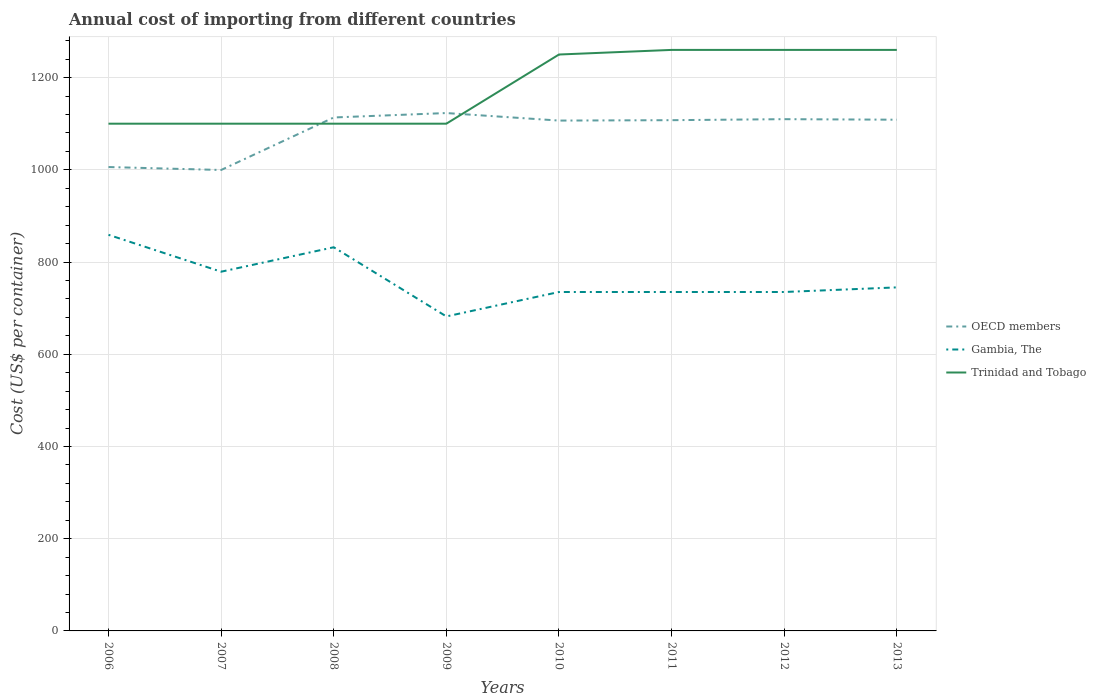How many different coloured lines are there?
Your answer should be very brief. 3. Across all years, what is the maximum total annual cost of importing in OECD members?
Give a very brief answer. 999.59. In which year was the total annual cost of importing in OECD members maximum?
Provide a short and direct response. 2007. What is the total total annual cost of importing in Trinidad and Tobago in the graph?
Give a very brief answer. -150. What is the difference between the highest and the second highest total annual cost of importing in Trinidad and Tobago?
Make the answer very short. 160. What is the difference between the highest and the lowest total annual cost of importing in OECD members?
Your response must be concise. 6. How many lines are there?
Ensure brevity in your answer.  3. What is the difference between two consecutive major ticks on the Y-axis?
Make the answer very short. 200. Are the values on the major ticks of Y-axis written in scientific E-notation?
Provide a succinct answer. No. Does the graph contain any zero values?
Your response must be concise. No. Does the graph contain grids?
Your answer should be very brief. Yes. What is the title of the graph?
Ensure brevity in your answer.  Annual cost of importing from different countries. Does "Sao Tome and Principe" appear as one of the legend labels in the graph?
Make the answer very short. No. What is the label or title of the X-axis?
Make the answer very short. Years. What is the label or title of the Y-axis?
Ensure brevity in your answer.  Cost (US$ per container). What is the Cost (US$ per container) in OECD members in 2006?
Your answer should be very brief. 1005.97. What is the Cost (US$ per container) in Gambia, The in 2006?
Give a very brief answer. 859. What is the Cost (US$ per container) in Trinidad and Tobago in 2006?
Ensure brevity in your answer.  1100. What is the Cost (US$ per container) of OECD members in 2007?
Make the answer very short. 999.59. What is the Cost (US$ per container) of Gambia, The in 2007?
Your response must be concise. 779. What is the Cost (US$ per container) in Trinidad and Tobago in 2007?
Your response must be concise. 1100. What is the Cost (US$ per container) of OECD members in 2008?
Ensure brevity in your answer.  1113.47. What is the Cost (US$ per container) in Gambia, The in 2008?
Offer a very short reply. 832. What is the Cost (US$ per container) of Trinidad and Tobago in 2008?
Make the answer very short. 1100. What is the Cost (US$ per container) in OECD members in 2009?
Offer a very short reply. 1123.06. What is the Cost (US$ per container) in Gambia, The in 2009?
Give a very brief answer. 682. What is the Cost (US$ per container) in Trinidad and Tobago in 2009?
Ensure brevity in your answer.  1100. What is the Cost (US$ per container) of OECD members in 2010?
Your answer should be compact. 1106.74. What is the Cost (US$ per container) in Gambia, The in 2010?
Your response must be concise. 735. What is the Cost (US$ per container) in Trinidad and Tobago in 2010?
Make the answer very short. 1250. What is the Cost (US$ per container) of OECD members in 2011?
Keep it short and to the point. 1107.59. What is the Cost (US$ per container) in Gambia, The in 2011?
Offer a terse response. 735. What is the Cost (US$ per container) in Trinidad and Tobago in 2011?
Provide a succinct answer. 1260. What is the Cost (US$ per container) of OECD members in 2012?
Your response must be concise. 1109.79. What is the Cost (US$ per container) of Gambia, The in 2012?
Your answer should be compact. 735. What is the Cost (US$ per container) of Trinidad and Tobago in 2012?
Make the answer very short. 1260. What is the Cost (US$ per container) in OECD members in 2013?
Give a very brief answer. 1108.61. What is the Cost (US$ per container) in Gambia, The in 2013?
Make the answer very short. 745. What is the Cost (US$ per container) of Trinidad and Tobago in 2013?
Offer a very short reply. 1260. Across all years, what is the maximum Cost (US$ per container) of OECD members?
Provide a succinct answer. 1123.06. Across all years, what is the maximum Cost (US$ per container) in Gambia, The?
Provide a short and direct response. 859. Across all years, what is the maximum Cost (US$ per container) in Trinidad and Tobago?
Your response must be concise. 1260. Across all years, what is the minimum Cost (US$ per container) of OECD members?
Provide a short and direct response. 999.59. Across all years, what is the minimum Cost (US$ per container) in Gambia, The?
Offer a very short reply. 682. Across all years, what is the minimum Cost (US$ per container) of Trinidad and Tobago?
Ensure brevity in your answer.  1100. What is the total Cost (US$ per container) of OECD members in the graph?
Offer a very short reply. 8674.82. What is the total Cost (US$ per container) of Gambia, The in the graph?
Offer a very short reply. 6102. What is the total Cost (US$ per container) in Trinidad and Tobago in the graph?
Offer a very short reply. 9430. What is the difference between the Cost (US$ per container) of OECD members in 2006 and that in 2007?
Provide a short and direct response. 6.38. What is the difference between the Cost (US$ per container) in OECD members in 2006 and that in 2008?
Provide a short and direct response. -107.5. What is the difference between the Cost (US$ per container) in Gambia, The in 2006 and that in 2008?
Provide a succinct answer. 27. What is the difference between the Cost (US$ per container) of OECD members in 2006 and that in 2009?
Your answer should be compact. -117.09. What is the difference between the Cost (US$ per container) of Gambia, The in 2006 and that in 2009?
Your response must be concise. 177. What is the difference between the Cost (US$ per container) in OECD members in 2006 and that in 2010?
Your response must be concise. -100.76. What is the difference between the Cost (US$ per container) in Gambia, The in 2006 and that in 2010?
Offer a very short reply. 124. What is the difference between the Cost (US$ per container) of Trinidad and Tobago in 2006 and that in 2010?
Offer a very short reply. -150. What is the difference between the Cost (US$ per container) in OECD members in 2006 and that in 2011?
Give a very brief answer. -101.62. What is the difference between the Cost (US$ per container) of Gambia, The in 2006 and that in 2011?
Your response must be concise. 124. What is the difference between the Cost (US$ per container) of Trinidad and Tobago in 2006 and that in 2011?
Provide a short and direct response. -160. What is the difference between the Cost (US$ per container) of OECD members in 2006 and that in 2012?
Make the answer very short. -103.82. What is the difference between the Cost (US$ per container) of Gambia, The in 2006 and that in 2012?
Your answer should be compact. 124. What is the difference between the Cost (US$ per container) of Trinidad and Tobago in 2006 and that in 2012?
Offer a very short reply. -160. What is the difference between the Cost (US$ per container) in OECD members in 2006 and that in 2013?
Make the answer very short. -102.64. What is the difference between the Cost (US$ per container) of Gambia, The in 2006 and that in 2013?
Ensure brevity in your answer.  114. What is the difference between the Cost (US$ per container) of Trinidad and Tobago in 2006 and that in 2013?
Offer a terse response. -160. What is the difference between the Cost (US$ per container) of OECD members in 2007 and that in 2008?
Offer a very short reply. -113.88. What is the difference between the Cost (US$ per container) of Gambia, The in 2007 and that in 2008?
Your response must be concise. -53. What is the difference between the Cost (US$ per container) of Trinidad and Tobago in 2007 and that in 2008?
Your answer should be very brief. 0. What is the difference between the Cost (US$ per container) of OECD members in 2007 and that in 2009?
Your answer should be very brief. -123.47. What is the difference between the Cost (US$ per container) of Gambia, The in 2007 and that in 2009?
Offer a terse response. 97. What is the difference between the Cost (US$ per container) in Trinidad and Tobago in 2007 and that in 2009?
Offer a very short reply. 0. What is the difference between the Cost (US$ per container) in OECD members in 2007 and that in 2010?
Provide a short and direct response. -107.15. What is the difference between the Cost (US$ per container) in Trinidad and Tobago in 2007 and that in 2010?
Keep it short and to the point. -150. What is the difference between the Cost (US$ per container) in OECD members in 2007 and that in 2011?
Your answer should be very brief. -108. What is the difference between the Cost (US$ per container) in Gambia, The in 2007 and that in 2011?
Your answer should be very brief. 44. What is the difference between the Cost (US$ per container) of Trinidad and Tobago in 2007 and that in 2011?
Ensure brevity in your answer.  -160. What is the difference between the Cost (US$ per container) of OECD members in 2007 and that in 2012?
Provide a succinct answer. -110.21. What is the difference between the Cost (US$ per container) in Trinidad and Tobago in 2007 and that in 2012?
Your answer should be compact. -160. What is the difference between the Cost (US$ per container) of OECD members in 2007 and that in 2013?
Provide a short and direct response. -109.03. What is the difference between the Cost (US$ per container) of Gambia, The in 2007 and that in 2013?
Your response must be concise. 34. What is the difference between the Cost (US$ per container) of Trinidad and Tobago in 2007 and that in 2013?
Provide a short and direct response. -160. What is the difference between the Cost (US$ per container) of OECD members in 2008 and that in 2009?
Make the answer very short. -9.59. What is the difference between the Cost (US$ per container) of Gambia, The in 2008 and that in 2009?
Your answer should be compact. 150. What is the difference between the Cost (US$ per container) in Trinidad and Tobago in 2008 and that in 2009?
Your answer should be very brief. 0. What is the difference between the Cost (US$ per container) of OECD members in 2008 and that in 2010?
Make the answer very short. 6.74. What is the difference between the Cost (US$ per container) of Gambia, The in 2008 and that in 2010?
Make the answer very short. 97. What is the difference between the Cost (US$ per container) in Trinidad and Tobago in 2008 and that in 2010?
Your response must be concise. -150. What is the difference between the Cost (US$ per container) of OECD members in 2008 and that in 2011?
Give a very brief answer. 5.88. What is the difference between the Cost (US$ per container) in Gambia, The in 2008 and that in 2011?
Provide a short and direct response. 97. What is the difference between the Cost (US$ per container) of Trinidad and Tobago in 2008 and that in 2011?
Give a very brief answer. -160. What is the difference between the Cost (US$ per container) of OECD members in 2008 and that in 2012?
Offer a terse response. 3.68. What is the difference between the Cost (US$ per container) of Gambia, The in 2008 and that in 2012?
Give a very brief answer. 97. What is the difference between the Cost (US$ per container) of Trinidad and Tobago in 2008 and that in 2012?
Your answer should be compact. -160. What is the difference between the Cost (US$ per container) in OECD members in 2008 and that in 2013?
Offer a very short reply. 4.86. What is the difference between the Cost (US$ per container) of Trinidad and Tobago in 2008 and that in 2013?
Ensure brevity in your answer.  -160. What is the difference between the Cost (US$ per container) in OECD members in 2009 and that in 2010?
Provide a short and direct response. 16.32. What is the difference between the Cost (US$ per container) of Gambia, The in 2009 and that in 2010?
Offer a very short reply. -53. What is the difference between the Cost (US$ per container) in Trinidad and Tobago in 2009 and that in 2010?
Your answer should be compact. -150. What is the difference between the Cost (US$ per container) of OECD members in 2009 and that in 2011?
Make the answer very short. 15.47. What is the difference between the Cost (US$ per container) of Gambia, The in 2009 and that in 2011?
Your answer should be very brief. -53. What is the difference between the Cost (US$ per container) of Trinidad and Tobago in 2009 and that in 2011?
Make the answer very short. -160. What is the difference between the Cost (US$ per container) in OECD members in 2009 and that in 2012?
Offer a very short reply. 13.26. What is the difference between the Cost (US$ per container) of Gambia, The in 2009 and that in 2012?
Ensure brevity in your answer.  -53. What is the difference between the Cost (US$ per container) in Trinidad and Tobago in 2009 and that in 2012?
Provide a succinct answer. -160. What is the difference between the Cost (US$ per container) in OECD members in 2009 and that in 2013?
Your answer should be very brief. 14.44. What is the difference between the Cost (US$ per container) in Gambia, The in 2009 and that in 2013?
Give a very brief answer. -63. What is the difference between the Cost (US$ per container) in Trinidad and Tobago in 2009 and that in 2013?
Offer a very short reply. -160. What is the difference between the Cost (US$ per container) in OECD members in 2010 and that in 2011?
Ensure brevity in your answer.  -0.85. What is the difference between the Cost (US$ per container) of Gambia, The in 2010 and that in 2011?
Your answer should be compact. 0. What is the difference between the Cost (US$ per container) of OECD members in 2010 and that in 2012?
Offer a terse response. -3.06. What is the difference between the Cost (US$ per container) in OECD members in 2010 and that in 2013?
Keep it short and to the point. -1.88. What is the difference between the Cost (US$ per container) in Trinidad and Tobago in 2010 and that in 2013?
Make the answer very short. -10. What is the difference between the Cost (US$ per container) in OECD members in 2011 and that in 2012?
Provide a short and direct response. -2.21. What is the difference between the Cost (US$ per container) in Trinidad and Tobago in 2011 and that in 2012?
Provide a short and direct response. 0. What is the difference between the Cost (US$ per container) of OECD members in 2011 and that in 2013?
Your answer should be compact. -1.03. What is the difference between the Cost (US$ per container) in Gambia, The in 2011 and that in 2013?
Keep it short and to the point. -10. What is the difference between the Cost (US$ per container) in Trinidad and Tobago in 2011 and that in 2013?
Your answer should be very brief. 0. What is the difference between the Cost (US$ per container) of OECD members in 2012 and that in 2013?
Keep it short and to the point. 1.18. What is the difference between the Cost (US$ per container) of Gambia, The in 2012 and that in 2013?
Your response must be concise. -10. What is the difference between the Cost (US$ per container) of Trinidad and Tobago in 2012 and that in 2013?
Offer a terse response. 0. What is the difference between the Cost (US$ per container) of OECD members in 2006 and the Cost (US$ per container) of Gambia, The in 2007?
Make the answer very short. 226.97. What is the difference between the Cost (US$ per container) of OECD members in 2006 and the Cost (US$ per container) of Trinidad and Tobago in 2007?
Offer a terse response. -94.03. What is the difference between the Cost (US$ per container) in Gambia, The in 2006 and the Cost (US$ per container) in Trinidad and Tobago in 2007?
Make the answer very short. -241. What is the difference between the Cost (US$ per container) of OECD members in 2006 and the Cost (US$ per container) of Gambia, The in 2008?
Your answer should be compact. 173.97. What is the difference between the Cost (US$ per container) of OECD members in 2006 and the Cost (US$ per container) of Trinidad and Tobago in 2008?
Give a very brief answer. -94.03. What is the difference between the Cost (US$ per container) in Gambia, The in 2006 and the Cost (US$ per container) in Trinidad and Tobago in 2008?
Provide a succinct answer. -241. What is the difference between the Cost (US$ per container) in OECD members in 2006 and the Cost (US$ per container) in Gambia, The in 2009?
Your response must be concise. 323.97. What is the difference between the Cost (US$ per container) of OECD members in 2006 and the Cost (US$ per container) of Trinidad and Tobago in 2009?
Keep it short and to the point. -94.03. What is the difference between the Cost (US$ per container) in Gambia, The in 2006 and the Cost (US$ per container) in Trinidad and Tobago in 2009?
Give a very brief answer. -241. What is the difference between the Cost (US$ per container) of OECD members in 2006 and the Cost (US$ per container) of Gambia, The in 2010?
Ensure brevity in your answer.  270.97. What is the difference between the Cost (US$ per container) of OECD members in 2006 and the Cost (US$ per container) of Trinidad and Tobago in 2010?
Provide a succinct answer. -244.03. What is the difference between the Cost (US$ per container) in Gambia, The in 2006 and the Cost (US$ per container) in Trinidad and Tobago in 2010?
Keep it short and to the point. -391. What is the difference between the Cost (US$ per container) of OECD members in 2006 and the Cost (US$ per container) of Gambia, The in 2011?
Keep it short and to the point. 270.97. What is the difference between the Cost (US$ per container) of OECD members in 2006 and the Cost (US$ per container) of Trinidad and Tobago in 2011?
Your response must be concise. -254.03. What is the difference between the Cost (US$ per container) of Gambia, The in 2006 and the Cost (US$ per container) of Trinidad and Tobago in 2011?
Offer a terse response. -401. What is the difference between the Cost (US$ per container) of OECD members in 2006 and the Cost (US$ per container) of Gambia, The in 2012?
Offer a terse response. 270.97. What is the difference between the Cost (US$ per container) of OECD members in 2006 and the Cost (US$ per container) of Trinidad and Tobago in 2012?
Your answer should be compact. -254.03. What is the difference between the Cost (US$ per container) of Gambia, The in 2006 and the Cost (US$ per container) of Trinidad and Tobago in 2012?
Your response must be concise. -401. What is the difference between the Cost (US$ per container) in OECD members in 2006 and the Cost (US$ per container) in Gambia, The in 2013?
Give a very brief answer. 260.97. What is the difference between the Cost (US$ per container) in OECD members in 2006 and the Cost (US$ per container) in Trinidad and Tobago in 2013?
Offer a terse response. -254.03. What is the difference between the Cost (US$ per container) of Gambia, The in 2006 and the Cost (US$ per container) of Trinidad and Tobago in 2013?
Provide a short and direct response. -401. What is the difference between the Cost (US$ per container) of OECD members in 2007 and the Cost (US$ per container) of Gambia, The in 2008?
Offer a terse response. 167.59. What is the difference between the Cost (US$ per container) in OECD members in 2007 and the Cost (US$ per container) in Trinidad and Tobago in 2008?
Your answer should be compact. -100.41. What is the difference between the Cost (US$ per container) in Gambia, The in 2007 and the Cost (US$ per container) in Trinidad and Tobago in 2008?
Offer a very short reply. -321. What is the difference between the Cost (US$ per container) in OECD members in 2007 and the Cost (US$ per container) in Gambia, The in 2009?
Provide a short and direct response. 317.59. What is the difference between the Cost (US$ per container) of OECD members in 2007 and the Cost (US$ per container) of Trinidad and Tobago in 2009?
Offer a very short reply. -100.41. What is the difference between the Cost (US$ per container) in Gambia, The in 2007 and the Cost (US$ per container) in Trinidad and Tobago in 2009?
Provide a succinct answer. -321. What is the difference between the Cost (US$ per container) in OECD members in 2007 and the Cost (US$ per container) in Gambia, The in 2010?
Your answer should be compact. 264.59. What is the difference between the Cost (US$ per container) in OECD members in 2007 and the Cost (US$ per container) in Trinidad and Tobago in 2010?
Keep it short and to the point. -250.41. What is the difference between the Cost (US$ per container) of Gambia, The in 2007 and the Cost (US$ per container) of Trinidad and Tobago in 2010?
Offer a very short reply. -471. What is the difference between the Cost (US$ per container) of OECD members in 2007 and the Cost (US$ per container) of Gambia, The in 2011?
Make the answer very short. 264.59. What is the difference between the Cost (US$ per container) of OECD members in 2007 and the Cost (US$ per container) of Trinidad and Tobago in 2011?
Keep it short and to the point. -260.41. What is the difference between the Cost (US$ per container) of Gambia, The in 2007 and the Cost (US$ per container) of Trinidad and Tobago in 2011?
Give a very brief answer. -481. What is the difference between the Cost (US$ per container) in OECD members in 2007 and the Cost (US$ per container) in Gambia, The in 2012?
Offer a very short reply. 264.59. What is the difference between the Cost (US$ per container) of OECD members in 2007 and the Cost (US$ per container) of Trinidad and Tobago in 2012?
Your response must be concise. -260.41. What is the difference between the Cost (US$ per container) of Gambia, The in 2007 and the Cost (US$ per container) of Trinidad and Tobago in 2012?
Keep it short and to the point. -481. What is the difference between the Cost (US$ per container) of OECD members in 2007 and the Cost (US$ per container) of Gambia, The in 2013?
Your response must be concise. 254.59. What is the difference between the Cost (US$ per container) in OECD members in 2007 and the Cost (US$ per container) in Trinidad and Tobago in 2013?
Your answer should be very brief. -260.41. What is the difference between the Cost (US$ per container) of Gambia, The in 2007 and the Cost (US$ per container) of Trinidad and Tobago in 2013?
Your answer should be very brief. -481. What is the difference between the Cost (US$ per container) of OECD members in 2008 and the Cost (US$ per container) of Gambia, The in 2009?
Keep it short and to the point. 431.47. What is the difference between the Cost (US$ per container) in OECD members in 2008 and the Cost (US$ per container) in Trinidad and Tobago in 2009?
Offer a terse response. 13.47. What is the difference between the Cost (US$ per container) in Gambia, The in 2008 and the Cost (US$ per container) in Trinidad and Tobago in 2009?
Your answer should be compact. -268. What is the difference between the Cost (US$ per container) of OECD members in 2008 and the Cost (US$ per container) of Gambia, The in 2010?
Provide a succinct answer. 378.47. What is the difference between the Cost (US$ per container) in OECD members in 2008 and the Cost (US$ per container) in Trinidad and Tobago in 2010?
Your answer should be compact. -136.53. What is the difference between the Cost (US$ per container) of Gambia, The in 2008 and the Cost (US$ per container) of Trinidad and Tobago in 2010?
Ensure brevity in your answer.  -418. What is the difference between the Cost (US$ per container) in OECD members in 2008 and the Cost (US$ per container) in Gambia, The in 2011?
Your response must be concise. 378.47. What is the difference between the Cost (US$ per container) of OECD members in 2008 and the Cost (US$ per container) of Trinidad and Tobago in 2011?
Make the answer very short. -146.53. What is the difference between the Cost (US$ per container) in Gambia, The in 2008 and the Cost (US$ per container) in Trinidad and Tobago in 2011?
Ensure brevity in your answer.  -428. What is the difference between the Cost (US$ per container) in OECD members in 2008 and the Cost (US$ per container) in Gambia, The in 2012?
Your response must be concise. 378.47. What is the difference between the Cost (US$ per container) in OECD members in 2008 and the Cost (US$ per container) in Trinidad and Tobago in 2012?
Your answer should be very brief. -146.53. What is the difference between the Cost (US$ per container) of Gambia, The in 2008 and the Cost (US$ per container) of Trinidad and Tobago in 2012?
Provide a succinct answer. -428. What is the difference between the Cost (US$ per container) in OECD members in 2008 and the Cost (US$ per container) in Gambia, The in 2013?
Ensure brevity in your answer.  368.47. What is the difference between the Cost (US$ per container) of OECD members in 2008 and the Cost (US$ per container) of Trinidad and Tobago in 2013?
Make the answer very short. -146.53. What is the difference between the Cost (US$ per container) in Gambia, The in 2008 and the Cost (US$ per container) in Trinidad and Tobago in 2013?
Your answer should be compact. -428. What is the difference between the Cost (US$ per container) in OECD members in 2009 and the Cost (US$ per container) in Gambia, The in 2010?
Offer a terse response. 388.06. What is the difference between the Cost (US$ per container) in OECD members in 2009 and the Cost (US$ per container) in Trinidad and Tobago in 2010?
Your answer should be very brief. -126.94. What is the difference between the Cost (US$ per container) in Gambia, The in 2009 and the Cost (US$ per container) in Trinidad and Tobago in 2010?
Provide a succinct answer. -568. What is the difference between the Cost (US$ per container) of OECD members in 2009 and the Cost (US$ per container) of Gambia, The in 2011?
Keep it short and to the point. 388.06. What is the difference between the Cost (US$ per container) in OECD members in 2009 and the Cost (US$ per container) in Trinidad and Tobago in 2011?
Your response must be concise. -136.94. What is the difference between the Cost (US$ per container) of Gambia, The in 2009 and the Cost (US$ per container) of Trinidad and Tobago in 2011?
Provide a short and direct response. -578. What is the difference between the Cost (US$ per container) in OECD members in 2009 and the Cost (US$ per container) in Gambia, The in 2012?
Your response must be concise. 388.06. What is the difference between the Cost (US$ per container) in OECD members in 2009 and the Cost (US$ per container) in Trinidad and Tobago in 2012?
Keep it short and to the point. -136.94. What is the difference between the Cost (US$ per container) in Gambia, The in 2009 and the Cost (US$ per container) in Trinidad and Tobago in 2012?
Ensure brevity in your answer.  -578. What is the difference between the Cost (US$ per container) of OECD members in 2009 and the Cost (US$ per container) of Gambia, The in 2013?
Ensure brevity in your answer.  378.06. What is the difference between the Cost (US$ per container) in OECD members in 2009 and the Cost (US$ per container) in Trinidad and Tobago in 2013?
Your answer should be compact. -136.94. What is the difference between the Cost (US$ per container) in Gambia, The in 2009 and the Cost (US$ per container) in Trinidad and Tobago in 2013?
Offer a terse response. -578. What is the difference between the Cost (US$ per container) of OECD members in 2010 and the Cost (US$ per container) of Gambia, The in 2011?
Your response must be concise. 371.74. What is the difference between the Cost (US$ per container) of OECD members in 2010 and the Cost (US$ per container) of Trinidad and Tobago in 2011?
Your answer should be very brief. -153.26. What is the difference between the Cost (US$ per container) in Gambia, The in 2010 and the Cost (US$ per container) in Trinidad and Tobago in 2011?
Provide a succinct answer. -525. What is the difference between the Cost (US$ per container) of OECD members in 2010 and the Cost (US$ per container) of Gambia, The in 2012?
Provide a short and direct response. 371.74. What is the difference between the Cost (US$ per container) in OECD members in 2010 and the Cost (US$ per container) in Trinidad and Tobago in 2012?
Ensure brevity in your answer.  -153.26. What is the difference between the Cost (US$ per container) in Gambia, The in 2010 and the Cost (US$ per container) in Trinidad and Tobago in 2012?
Provide a short and direct response. -525. What is the difference between the Cost (US$ per container) of OECD members in 2010 and the Cost (US$ per container) of Gambia, The in 2013?
Offer a terse response. 361.74. What is the difference between the Cost (US$ per container) in OECD members in 2010 and the Cost (US$ per container) in Trinidad and Tobago in 2013?
Ensure brevity in your answer.  -153.26. What is the difference between the Cost (US$ per container) in Gambia, The in 2010 and the Cost (US$ per container) in Trinidad and Tobago in 2013?
Provide a short and direct response. -525. What is the difference between the Cost (US$ per container) of OECD members in 2011 and the Cost (US$ per container) of Gambia, The in 2012?
Your answer should be very brief. 372.59. What is the difference between the Cost (US$ per container) of OECD members in 2011 and the Cost (US$ per container) of Trinidad and Tobago in 2012?
Make the answer very short. -152.41. What is the difference between the Cost (US$ per container) of Gambia, The in 2011 and the Cost (US$ per container) of Trinidad and Tobago in 2012?
Offer a terse response. -525. What is the difference between the Cost (US$ per container) in OECD members in 2011 and the Cost (US$ per container) in Gambia, The in 2013?
Ensure brevity in your answer.  362.59. What is the difference between the Cost (US$ per container) in OECD members in 2011 and the Cost (US$ per container) in Trinidad and Tobago in 2013?
Offer a terse response. -152.41. What is the difference between the Cost (US$ per container) in Gambia, The in 2011 and the Cost (US$ per container) in Trinidad and Tobago in 2013?
Offer a terse response. -525. What is the difference between the Cost (US$ per container) in OECD members in 2012 and the Cost (US$ per container) in Gambia, The in 2013?
Your answer should be compact. 364.79. What is the difference between the Cost (US$ per container) of OECD members in 2012 and the Cost (US$ per container) of Trinidad and Tobago in 2013?
Your answer should be compact. -150.21. What is the difference between the Cost (US$ per container) of Gambia, The in 2012 and the Cost (US$ per container) of Trinidad and Tobago in 2013?
Provide a succinct answer. -525. What is the average Cost (US$ per container) of OECD members per year?
Offer a very short reply. 1084.35. What is the average Cost (US$ per container) of Gambia, The per year?
Give a very brief answer. 762.75. What is the average Cost (US$ per container) of Trinidad and Tobago per year?
Give a very brief answer. 1178.75. In the year 2006, what is the difference between the Cost (US$ per container) of OECD members and Cost (US$ per container) of Gambia, The?
Offer a very short reply. 146.97. In the year 2006, what is the difference between the Cost (US$ per container) of OECD members and Cost (US$ per container) of Trinidad and Tobago?
Offer a terse response. -94.03. In the year 2006, what is the difference between the Cost (US$ per container) in Gambia, The and Cost (US$ per container) in Trinidad and Tobago?
Make the answer very short. -241. In the year 2007, what is the difference between the Cost (US$ per container) of OECD members and Cost (US$ per container) of Gambia, The?
Your response must be concise. 220.59. In the year 2007, what is the difference between the Cost (US$ per container) in OECD members and Cost (US$ per container) in Trinidad and Tobago?
Give a very brief answer. -100.41. In the year 2007, what is the difference between the Cost (US$ per container) of Gambia, The and Cost (US$ per container) of Trinidad and Tobago?
Offer a very short reply. -321. In the year 2008, what is the difference between the Cost (US$ per container) of OECD members and Cost (US$ per container) of Gambia, The?
Ensure brevity in your answer.  281.47. In the year 2008, what is the difference between the Cost (US$ per container) of OECD members and Cost (US$ per container) of Trinidad and Tobago?
Keep it short and to the point. 13.47. In the year 2008, what is the difference between the Cost (US$ per container) of Gambia, The and Cost (US$ per container) of Trinidad and Tobago?
Keep it short and to the point. -268. In the year 2009, what is the difference between the Cost (US$ per container) in OECD members and Cost (US$ per container) in Gambia, The?
Keep it short and to the point. 441.06. In the year 2009, what is the difference between the Cost (US$ per container) in OECD members and Cost (US$ per container) in Trinidad and Tobago?
Provide a short and direct response. 23.06. In the year 2009, what is the difference between the Cost (US$ per container) in Gambia, The and Cost (US$ per container) in Trinidad and Tobago?
Ensure brevity in your answer.  -418. In the year 2010, what is the difference between the Cost (US$ per container) of OECD members and Cost (US$ per container) of Gambia, The?
Make the answer very short. 371.74. In the year 2010, what is the difference between the Cost (US$ per container) of OECD members and Cost (US$ per container) of Trinidad and Tobago?
Give a very brief answer. -143.26. In the year 2010, what is the difference between the Cost (US$ per container) in Gambia, The and Cost (US$ per container) in Trinidad and Tobago?
Make the answer very short. -515. In the year 2011, what is the difference between the Cost (US$ per container) in OECD members and Cost (US$ per container) in Gambia, The?
Ensure brevity in your answer.  372.59. In the year 2011, what is the difference between the Cost (US$ per container) of OECD members and Cost (US$ per container) of Trinidad and Tobago?
Offer a very short reply. -152.41. In the year 2011, what is the difference between the Cost (US$ per container) of Gambia, The and Cost (US$ per container) of Trinidad and Tobago?
Your response must be concise. -525. In the year 2012, what is the difference between the Cost (US$ per container) in OECD members and Cost (US$ per container) in Gambia, The?
Provide a short and direct response. 374.79. In the year 2012, what is the difference between the Cost (US$ per container) in OECD members and Cost (US$ per container) in Trinidad and Tobago?
Ensure brevity in your answer.  -150.21. In the year 2012, what is the difference between the Cost (US$ per container) in Gambia, The and Cost (US$ per container) in Trinidad and Tobago?
Provide a succinct answer. -525. In the year 2013, what is the difference between the Cost (US$ per container) in OECD members and Cost (US$ per container) in Gambia, The?
Offer a terse response. 363.61. In the year 2013, what is the difference between the Cost (US$ per container) in OECD members and Cost (US$ per container) in Trinidad and Tobago?
Provide a succinct answer. -151.39. In the year 2013, what is the difference between the Cost (US$ per container) in Gambia, The and Cost (US$ per container) in Trinidad and Tobago?
Your answer should be compact. -515. What is the ratio of the Cost (US$ per container) of OECD members in 2006 to that in 2007?
Offer a terse response. 1.01. What is the ratio of the Cost (US$ per container) in Gambia, The in 2006 to that in 2007?
Make the answer very short. 1.1. What is the ratio of the Cost (US$ per container) of OECD members in 2006 to that in 2008?
Offer a very short reply. 0.9. What is the ratio of the Cost (US$ per container) in Gambia, The in 2006 to that in 2008?
Provide a short and direct response. 1.03. What is the ratio of the Cost (US$ per container) of OECD members in 2006 to that in 2009?
Give a very brief answer. 0.9. What is the ratio of the Cost (US$ per container) of Gambia, The in 2006 to that in 2009?
Give a very brief answer. 1.26. What is the ratio of the Cost (US$ per container) of OECD members in 2006 to that in 2010?
Offer a terse response. 0.91. What is the ratio of the Cost (US$ per container) in Gambia, The in 2006 to that in 2010?
Your answer should be compact. 1.17. What is the ratio of the Cost (US$ per container) of OECD members in 2006 to that in 2011?
Offer a terse response. 0.91. What is the ratio of the Cost (US$ per container) in Gambia, The in 2006 to that in 2011?
Offer a very short reply. 1.17. What is the ratio of the Cost (US$ per container) of Trinidad and Tobago in 2006 to that in 2011?
Ensure brevity in your answer.  0.87. What is the ratio of the Cost (US$ per container) of OECD members in 2006 to that in 2012?
Keep it short and to the point. 0.91. What is the ratio of the Cost (US$ per container) of Gambia, The in 2006 to that in 2012?
Provide a succinct answer. 1.17. What is the ratio of the Cost (US$ per container) of Trinidad and Tobago in 2006 to that in 2012?
Ensure brevity in your answer.  0.87. What is the ratio of the Cost (US$ per container) of OECD members in 2006 to that in 2013?
Offer a very short reply. 0.91. What is the ratio of the Cost (US$ per container) in Gambia, The in 2006 to that in 2013?
Ensure brevity in your answer.  1.15. What is the ratio of the Cost (US$ per container) in Trinidad and Tobago in 2006 to that in 2013?
Provide a short and direct response. 0.87. What is the ratio of the Cost (US$ per container) in OECD members in 2007 to that in 2008?
Provide a short and direct response. 0.9. What is the ratio of the Cost (US$ per container) of Gambia, The in 2007 to that in 2008?
Ensure brevity in your answer.  0.94. What is the ratio of the Cost (US$ per container) of OECD members in 2007 to that in 2009?
Ensure brevity in your answer.  0.89. What is the ratio of the Cost (US$ per container) of Gambia, The in 2007 to that in 2009?
Provide a short and direct response. 1.14. What is the ratio of the Cost (US$ per container) of Trinidad and Tobago in 2007 to that in 2009?
Offer a very short reply. 1. What is the ratio of the Cost (US$ per container) of OECD members in 2007 to that in 2010?
Your answer should be compact. 0.9. What is the ratio of the Cost (US$ per container) of Gambia, The in 2007 to that in 2010?
Your response must be concise. 1.06. What is the ratio of the Cost (US$ per container) in OECD members in 2007 to that in 2011?
Ensure brevity in your answer.  0.9. What is the ratio of the Cost (US$ per container) of Gambia, The in 2007 to that in 2011?
Offer a very short reply. 1.06. What is the ratio of the Cost (US$ per container) in Trinidad and Tobago in 2007 to that in 2011?
Provide a short and direct response. 0.87. What is the ratio of the Cost (US$ per container) of OECD members in 2007 to that in 2012?
Give a very brief answer. 0.9. What is the ratio of the Cost (US$ per container) of Gambia, The in 2007 to that in 2012?
Make the answer very short. 1.06. What is the ratio of the Cost (US$ per container) in Trinidad and Tobago in 2007 to that in 2012?
Keep it short and to the point. 0.87. What is the ratio of the Cost (US$ per container) in OECD members in 2007 to that in 2013?
Keep it short and to the point. 0.9. What is the ratio of the Cost (US$ per container) of Gambia, The in 2007 to that in 2013?
Offer a very short reply. 1.05. What is the ratio of the Cost (US$ per container) in Trinidad and Tobago in 2007 to that in 2013?
Your answer should be compact. 0.87. What is the ratio of the Cost (US$ per container) in OECD members in 2008 to that in 2009?
Your answer should be compact. 0.99. What is the ratio of the Cost (US$ per container) of Gambia, The in 2008 to that in 2009?
Your answer should be compact. 1.22. What is the ratio of the Cost (US$ per container) of Trinidad and Tobago in 2008 to that in 2009?
Ensure brevity in your answer.  1. What is the ratio of the Cost (US$ per container) of Gambia, The in 2008 to that in 2010?
Your answer should be very brief. 1.13. What is the ratio of the Cost (US$ per container) of Gambia, The in 2008 to that in 2011?
Your response must be concise. 1.13. What is the ratio of the Cost (US$ per container) in Trinidad and Tobago in 2008 to that in 2011?
Offer a very short reply. 0.87. What is the ratio of the Cost (US$ per container) of OECD members in 2008 to that in 2012?
Your response must be concise. 1. What is the ratio of the Cost (US$ per container) in Gambia, The in 2008 to that in 2012?
Your answer should be very brief. 1.13. What is the ratio of the Cost (US$ per container) of Trinidad and Tobago in 2008 to that in 2012?
Keep it short and to the point. 0.87. What is the ratio of the Cost (US$ per container) in OECD members in 2008 to that in 2013?
Your response must be concise. 1. What is the ratio of the Cost (US$ per container) of Gambia, The in 2008 to that in 2013?
Your answer should be compact. 1.12. What is the ratio of the Cost (US$ per container) of Trinidad and Tobago in 2008 to that in 2013?
Your response must be concise. 0.87. What is the ratio of the Cost (US$ per container) in OECD members in 2009 to that in 2010?
Your answer should be very brief. 1.01. What is the ratio of the Cost (US$ per container) in Gambia, The in 2009 to that in 2010?
Keep it short and to the point. 0.93. What is the ratio of the Cost (US$ per container) in OECD members in 2009 to that in 2011?
Give a very brief answer. 1.01. What is the ratio of the Cost (US$ per container) of Gambia, The in 2009 to that in 2011?
Your answer should be very brief. 0.93. What is the ratio of the Cost (US$ per container) of Trinidad and Tobago in 2009 to that in 2011?
Your answer should be compact. 0.87. What is the ratio of the Cost (US$ per container) in Gambia, The in 2009 to that in 2012?
Offer a terse response. 0.93. What is the ratio of the Cost (US$ per container) in Trinidad and Tobago in 2009 to that in 2012?
Ensure brevity in your answer.  0.87. What is the ratio of the Cost (US$ per container) in OECD members in 2009 to that in 2013?
Provide a succinct answer. 1.01. What is the ratio of the Cost (US$ per container) of Gambia, The in 2009 to that in 2013?
Make the answer very short. 0.92. What is the ratio of the Cost (US$ per container) in Trinidad and Tobago in 2009 to that in 2013?
Your answer should be very brief. 0.87. What is the ratio of the Cost (US$ per container) of OECD members in 2010 to that in 2011?
Offer a terse response. 1. What is the ratio of the Cost (US$ per container) of Gambia, The in 2010 to that in 2013?
Your response must be concise. 0.99. What is the ratio of the Cost (US$ per container) of OECD members in 2011 to that in 2012?
Provide a succinct answer. 1. What is the ratio of the Cost (US$ per container) of Gambia, The in 2011 to that in 2012?
Offer a very short reply. 1. What is the ratio of the Cost (US$ per container) of OECD members in 2011 to that in 2013?
Keep it short and to the point. 1. What is the ratio of the Cost (US$ per container) in Gambia, The in 2011 to that in 2013?
Give a very brief answer. 0.99. What is the ratio of the Cost (US$ per container) of OECD members in 2012 to that in 2013?
Offer a very short reply. 1. What is the ratio of the Cost (US$ per container) of Gambia, The in 2012 to that in 2013?
Offer a very short reply. 0.99. What is the difference between the highest and the second highest Cost (US$ per container) of OECD members?
Make the answer very short. 9.59. What is the difference between the highest and the second highest Cost (US$ per container) of Gambia, The?
Give a very brief answer. 27. What is the difference between the highest and the second highest Cost (US$ per container) of Trinidad and Tobago?
Give a very brief answer. 0. What is the difference between the highest and the lowest Cost (US$ per container) in OECD members?
Make the answer very short. 123.47. What is the difference between the highest and the lowest Cost (US$ per container) in Gambia, The?
Offer a very short reply. 177. What is the difference between the highest and the lowest Cost (US$ per container) of Trinidad and Tobago?
Your answer should be compact. 160. 